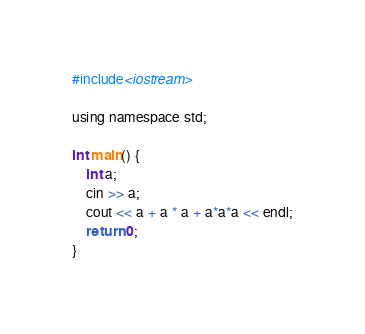Convert code to text. <code><loc_0><loc_0><loc_500><loc_500><_C_>#include<iostream>

using namespace std;

int main() {
    int a;
    cin >> a;
    cout << a + a * a + a*a*a << endl;
    return 0;
}

</code> 